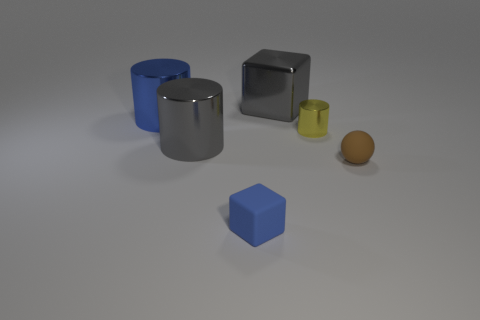Add 3 cyan matte things. How many objects exist? 9 Subtract all blocks. How many objects are left? 4 Add 3 brown matte objects. How many brown matte objects are left? 4 Add 6 big red metallic cylinders. How many big red metallic cylinders exist? 6 Subtract 0 purple cubes. How many objects are left? 6 Subtract all small cylinders. Subtract all tiny cyan things. How many objects are left? 5 